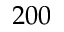<formula> <loc_0><loc_0><loc_500><loc_500>2 0 0</formula> 